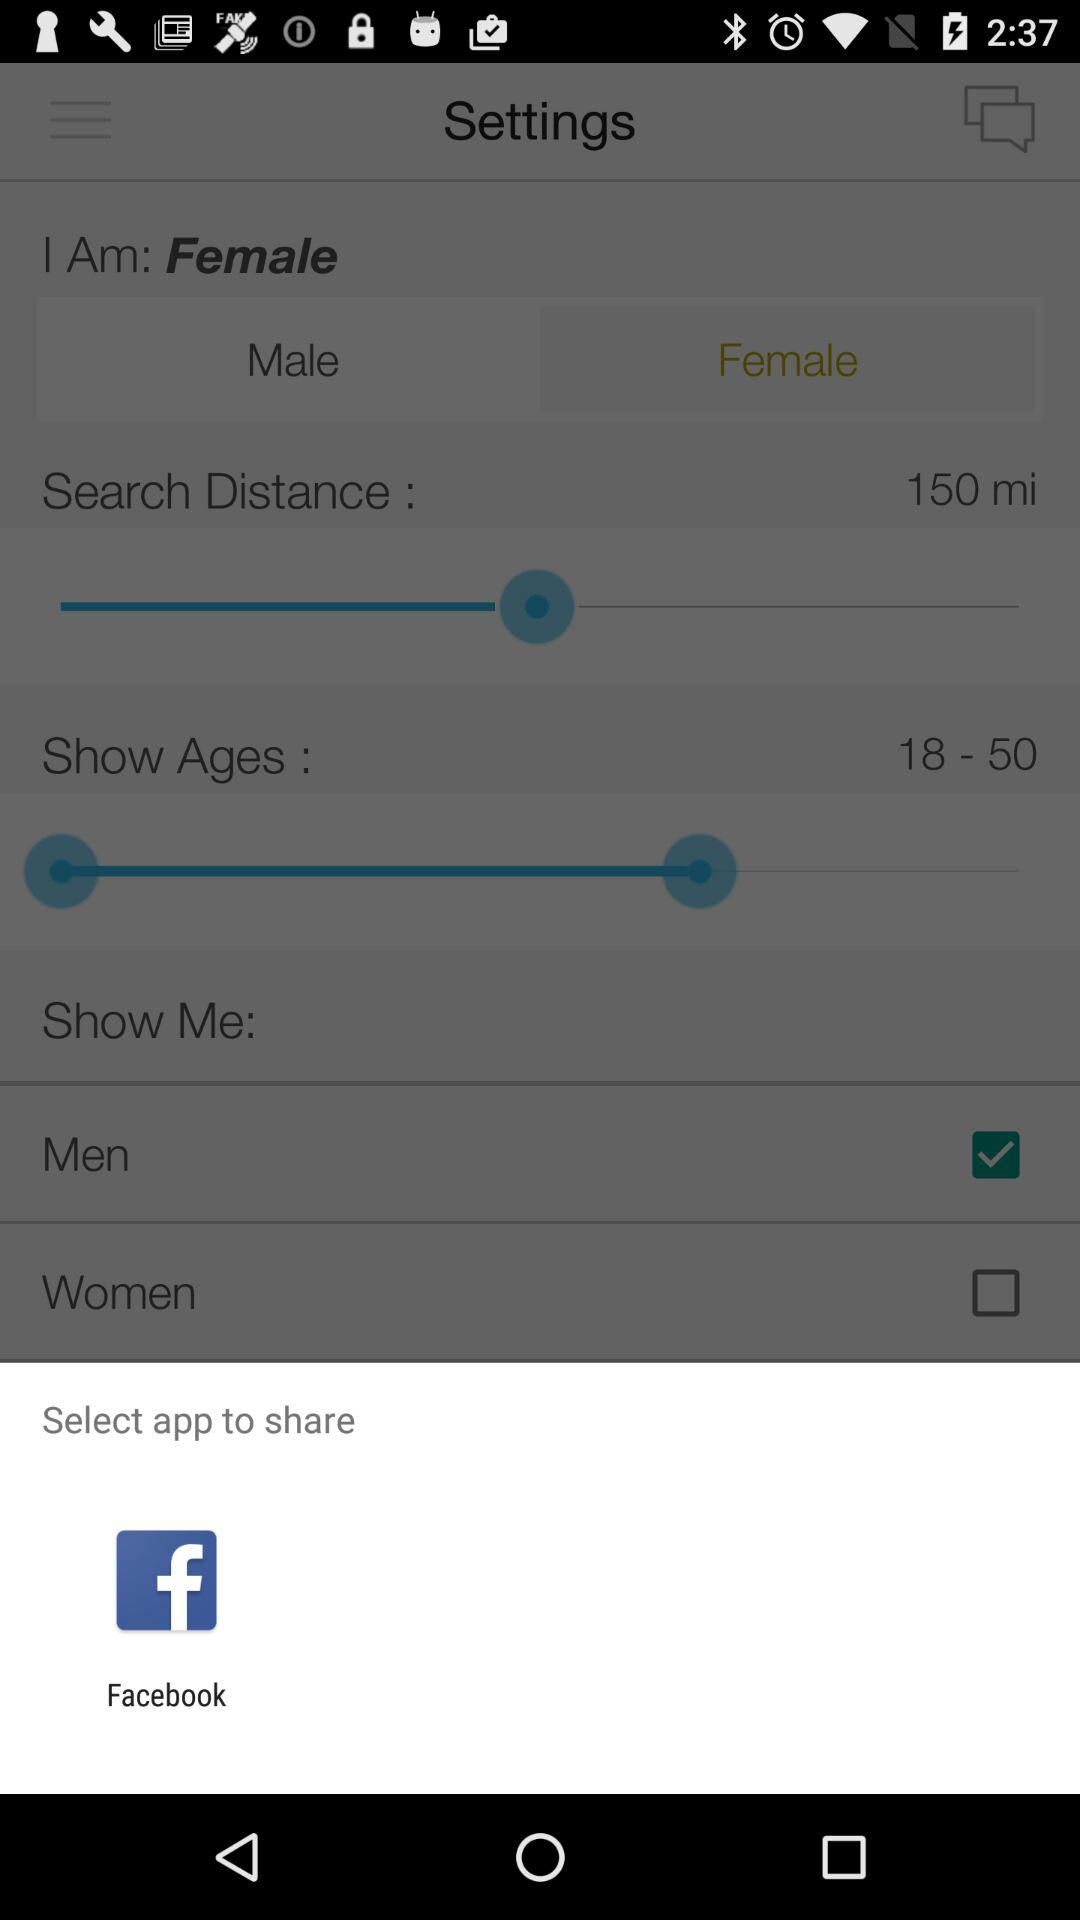What is the age group? The age group is 18 to 50 years. 